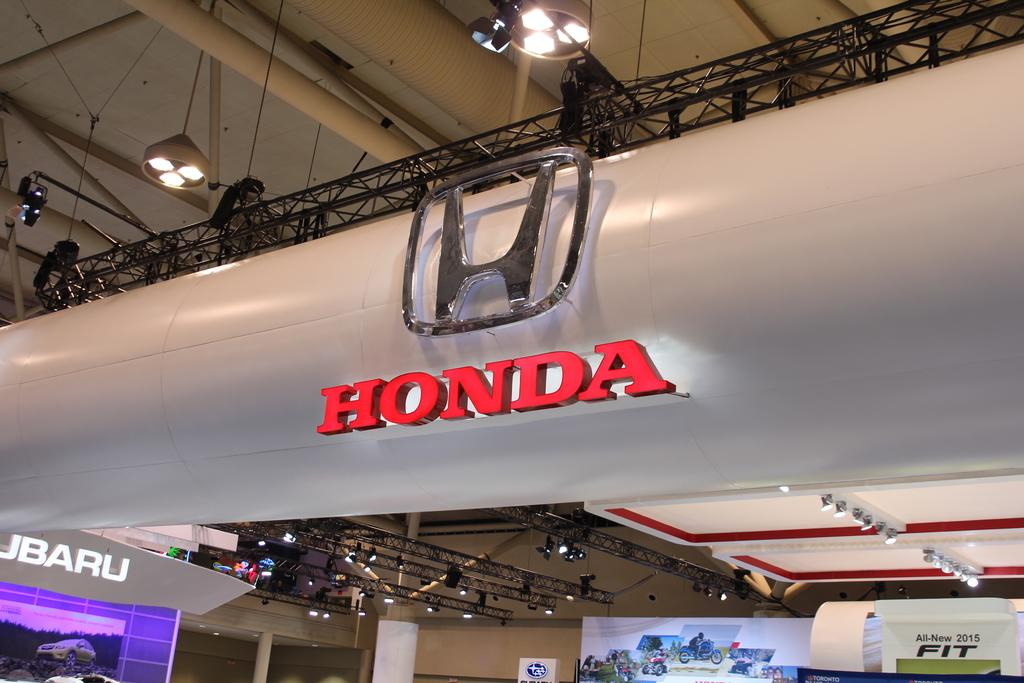Which car brand do you see?
Give a very brief answer. Honda. 